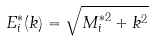Convert formula to latex. <formula><loc_0><loc_0><loc_500><loc_500>E _ { i } ^ { \ast } ( k ) = \sqrt { M _ { i } ^ { \ast 2 } + k ^ { 2 } }</formula> 